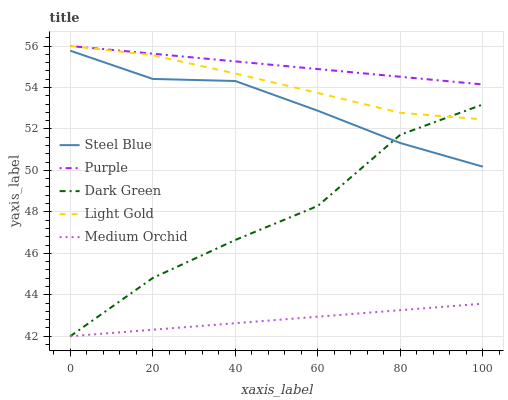Does Light Gold have the minimum area under the curve?
Answer yes or no. No. Does Light Gold have the maximum area under the curve?
Answer yes or no. No. Is Medium Orchid the smoothest?
Answer yes or no. No. Is Medium Orchid the roughest?
Answer yes or no. No. Does Light Gold have the lowest value?
Answer yes or no. No. Does Medium Orchid have the highest value?
Answer yes or no. No. Is Medium Orchid less than Steel Blue?
Answer yes or no. Yes. Is Purple greater than Medium Orchid?
Answer yes or no. Yes. Does Medium Orchid intersect Steel Blue?
Answer yes or no. No. 